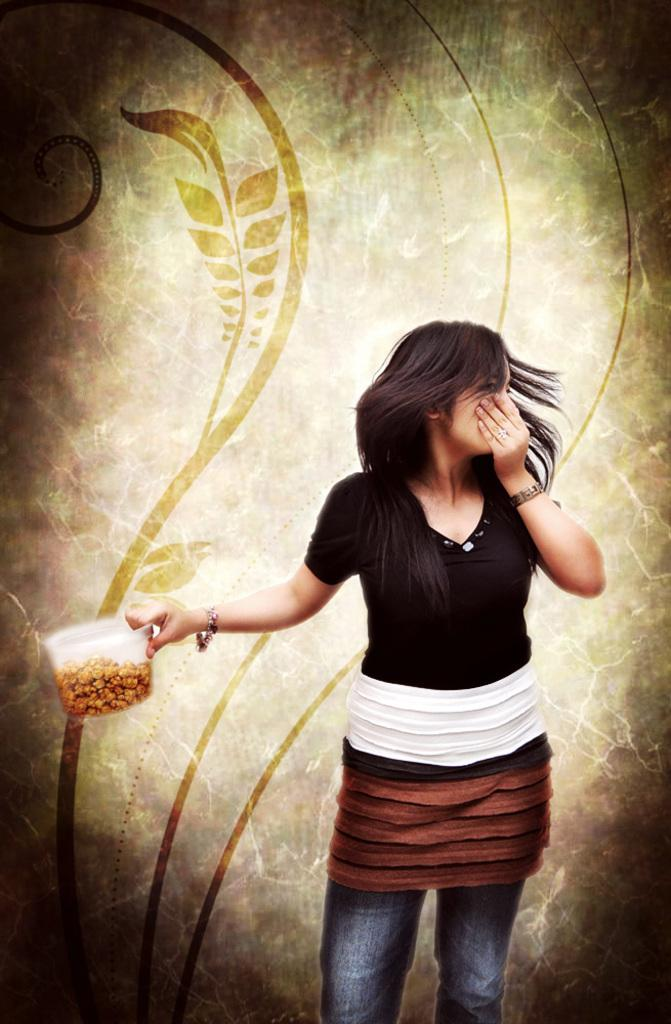Who is the main subject in the image? There is a woman in the image. What is the woman wearing? The woman is wearing a black t-shirt and jeans. What is the woman holding in the image? The woman is holding a mug with food in it. Can you describe any other visual elements in the image? There is a graphic design visible in the image. What type of watch is the woman wearing in the image? The woman is not wearing a watch in the image. What shape is the calculator on the table in the image? There is no calculator present in the image. 